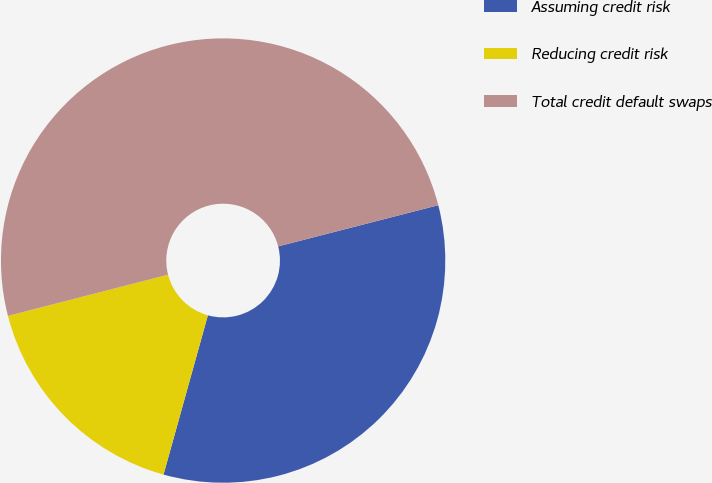<chart> <loc_0><loc_0><loc_500><loc_500><pie_chart><fcel>Assuming credit risk<fcel>Reducing credit risk<fcel>Total credit default swaps<nl><fcel>33.33%<fcel>16.67%<fcel>50.0%<nl></chart> 